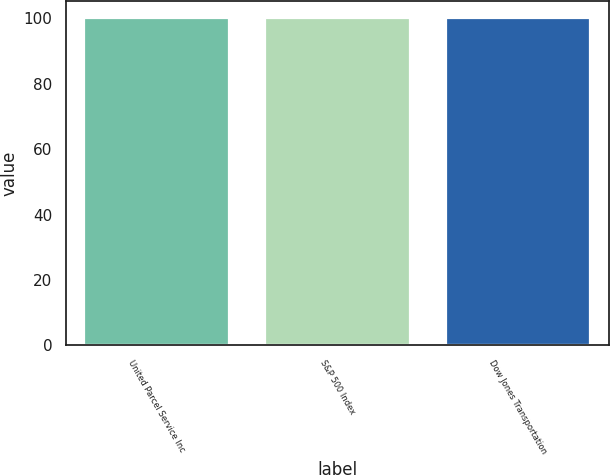Convert chart to OTSL. <chart><loc_0><loc_0><loc_500><loc_500><bar_chart><fcel>United Parcel Service Inc<fcel>S&P 500 Index<fcel>Dow Jones Transportation<nl><fcel>100<fcel>100.1<fcel>100.2<nl></chart> 